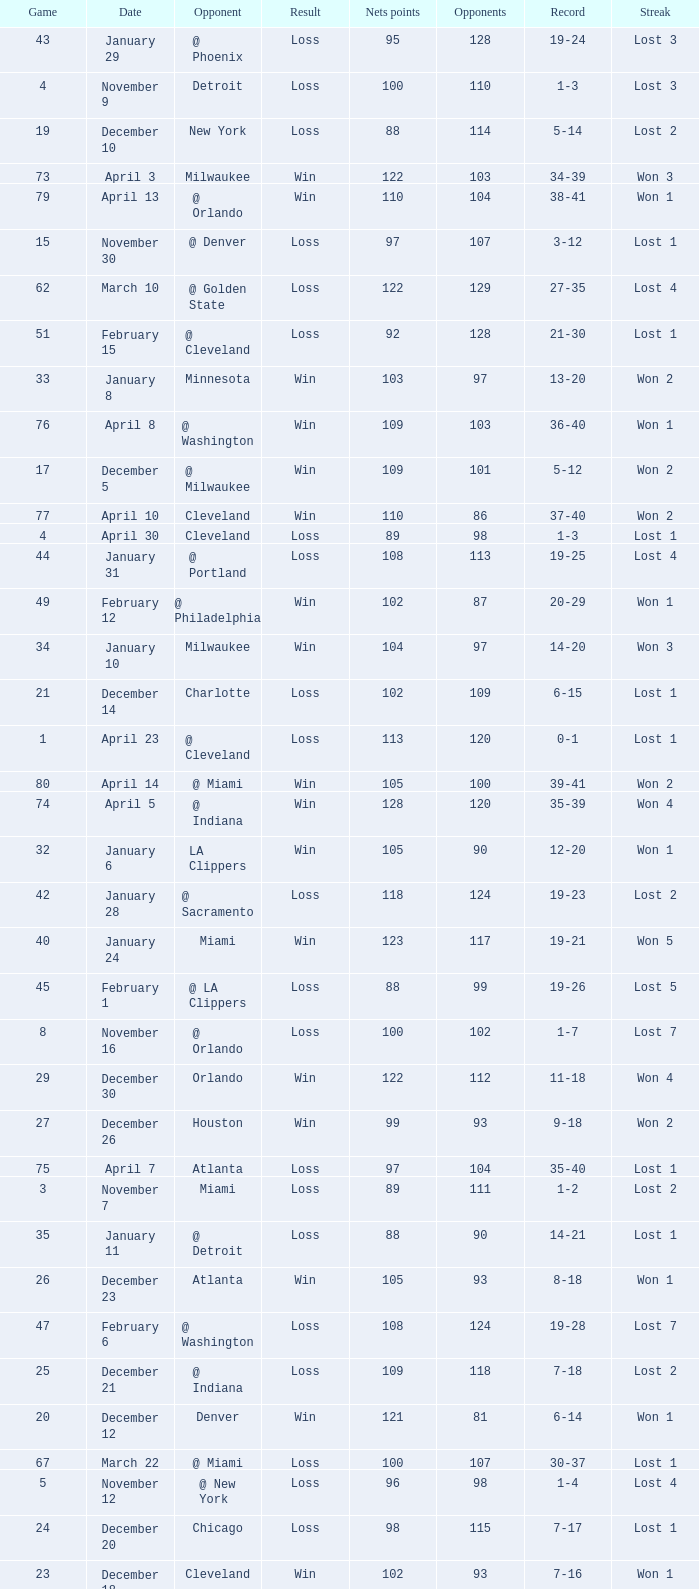How many opponents were there in a game higher than 20 on January 28? 124.0. 